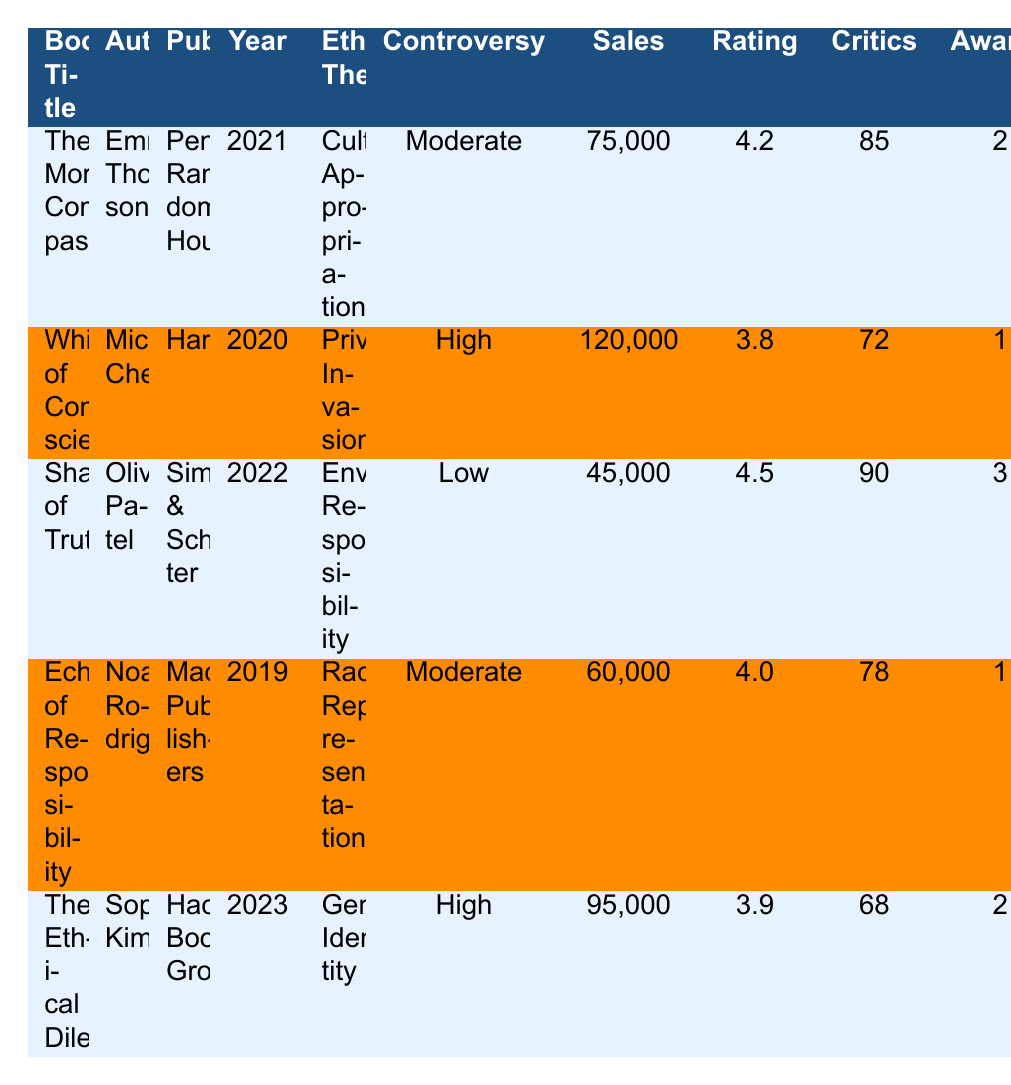What is the highest number of book club selections among the listed books? Looking at the "Book Club Selections" column, "Shadows of Truth" has 22 selections, which is more than any other book in the table.
Answer: 22 What is the average Goodreads rating of the books? The Goodreads ratings are 4.2, 3.8, 4.5, 4.0, and 3.9. Adding them gives 20.4. Dividing by 5 (the number of books) results in an average of 4.08.
Answer: 4.08 Was "Shadows of Truth" nominated for more awards than "Whispers of Conscience"? "Shadows of Truth" has 3 nominations, while "Whispers of Conscience" has 1. Therefore, yes, "Shadows of Truth" is nominated for more awards.
Answer: Yes Which book had the highest first-year sales, and what was the associated ethical theme? "Whispers of Conscience" had the highest first-year sales at 120,000 with the ethical theme of "Privacy Invasion."
Answer: Whispers of Conscience; Privacy Invasion Does there seem to be a correlation between controversy level and sales numbers? The books with high controversy levels ("Whispers of Conscience" and "The Ethical Dilemma") had sales of 120,000 and 95,000 respectively, while moderate controversy (two books) had 75,000 and 60,000 sales, and the low controversy book had only 45,000 sales. This suggests a positive correlation.
Answer: Yes What is the total number of sensitivity readers employed across all books? Summing up the "Sensitivity Readers Employed" column gives 2 + 4 + 1 + 3 + 5 = 15.
Answer: 15 Which book had the lowest critical reception score and what was its ethical theme? "The Ethical Dilemma" had the lowest score of 68, with the ethical theme of "Gender Identity."
Answer: The Ethical Dilemma; Gender Identity Do all authors in the table have at least 25,000 social media followers? No, "Shadows of Truth" has only 15,000 followers, which is below the 25,000 threshold.
Answer: No Which book associated with a high controversy level had the best Goodreads rating? "The Ethical Dilemma" with high controversy had a Goodreads rating of 3.9, while "Whispers of Conscience," also high controversy, has a rating of 3.8. Therefore, "The Ethical Dilemma" has the best rating among the high controversy level books.
Answer: The Ethical Dilemma What is the difference in first-year sales between the book with the highest sales and the book with the lowest? First-year sales of "Whispers of Conscience" (120,000) minus "Shadows of Truth" (45,000) results in a difference of 75,000.
Answer: 75,000 How many ethical consultations did the author of "The Moral Compass" have? The table indicates that the author of "The Moral Compass," Emma Thompson, had 3 ethical consultations.
Answer: 3 